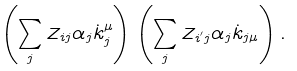<formula> <loc_0><loc_0><loc_500><loc_500>\left ( \sum _ { j } Z _ { i j } \alpha _ { j } \dot { k } _ { j } ^ { \mu } \right ) \left ( \sum _ { j } Z _ { i ^ { ^ { \prime } } j } \alpha _ { j } \dot { k } _ { j \mu } \right ) .</formula> 